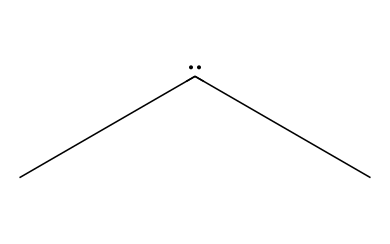What is the total number of carbon atoms in this structure? The SMILES representation shows two carbon atoms at the beginning (C) and indicates two additional carbon atoms attached to it via the branches represented by (C). Therefore, there are a total of four carbon atoms in the structure.
Answer: four How many hydrogen atoms are attached to the carbon atoms in dimethylcarbene? Each of the four carbon atoms in dimethylcarbene is sp² hybridized. Since it has two substituents (methyl groups), there are three hydrogen atoms attached to each of the two terminal carbon atoms and no hydrogen on the central carbon. This gives a total of 3 + 3 = 6 hydrogen atoms.
Answer: six What type of linkage represents the structural characteristic of dimethylcarbene? Dimethylcarbene has a unique and reactive nature due to the presence of the divalent carbon atom at the center, which leads to a carbenic structure. This center carbon does not have the typical tetravalent bonding.
Answer: carbenic Is dimethylcarbene stable enough for applications in polymer coatings? Dimethylcarbene is a highly reactive intermediate and is often not stable under ambient conditions. Its reactivity could lead to undesired side reactions in polymer coatings.
Answer: no How does the presence of dimethylcarbene affect polymer properties? The presence of a reactive species like dimethylcarbene in a polymer matrix can lead to enhanced cross-linking potential, improved adhesion, and overall modification of polymer properties through chemical reactions during the curing process.
Answer: enhanced cross-linking 